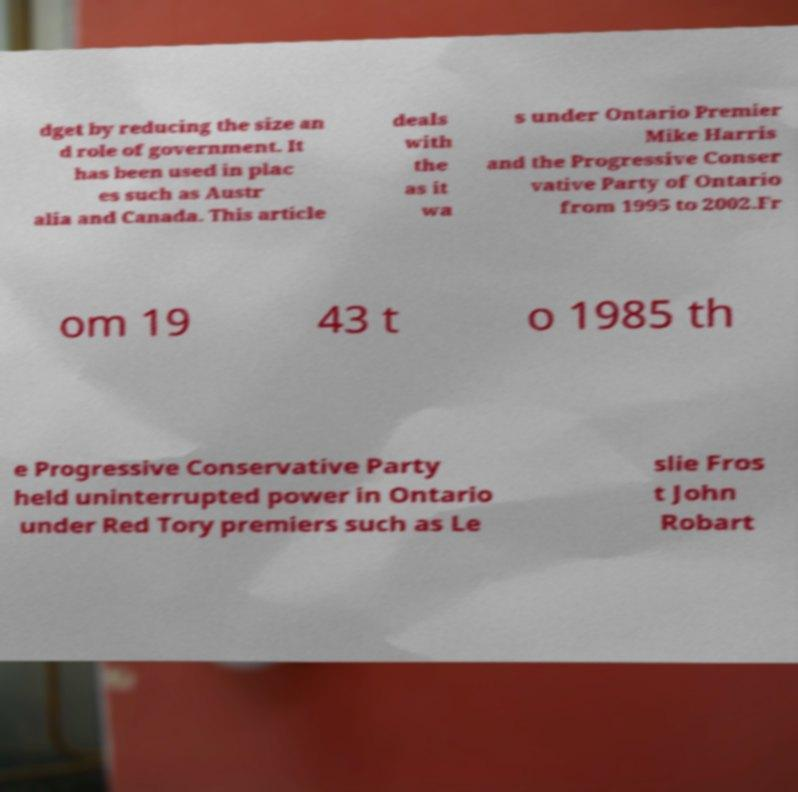Could you assist in decoding the text presented in this image and type it out clearly? dget by reducing the size an d role of government. It has been used in plac es such as Austr alia and Canada. This article deals with the as it wa s under Ontario Premier Mike Harris and the Progressive Conser vative Party of Ontario from 1995 to 2002.Fr om 19 43 t o 1985 th e Progressive Conservative Party held uninterrupted power in Ontario under Red Tory premiers such as Le slie Fros t John Robart 